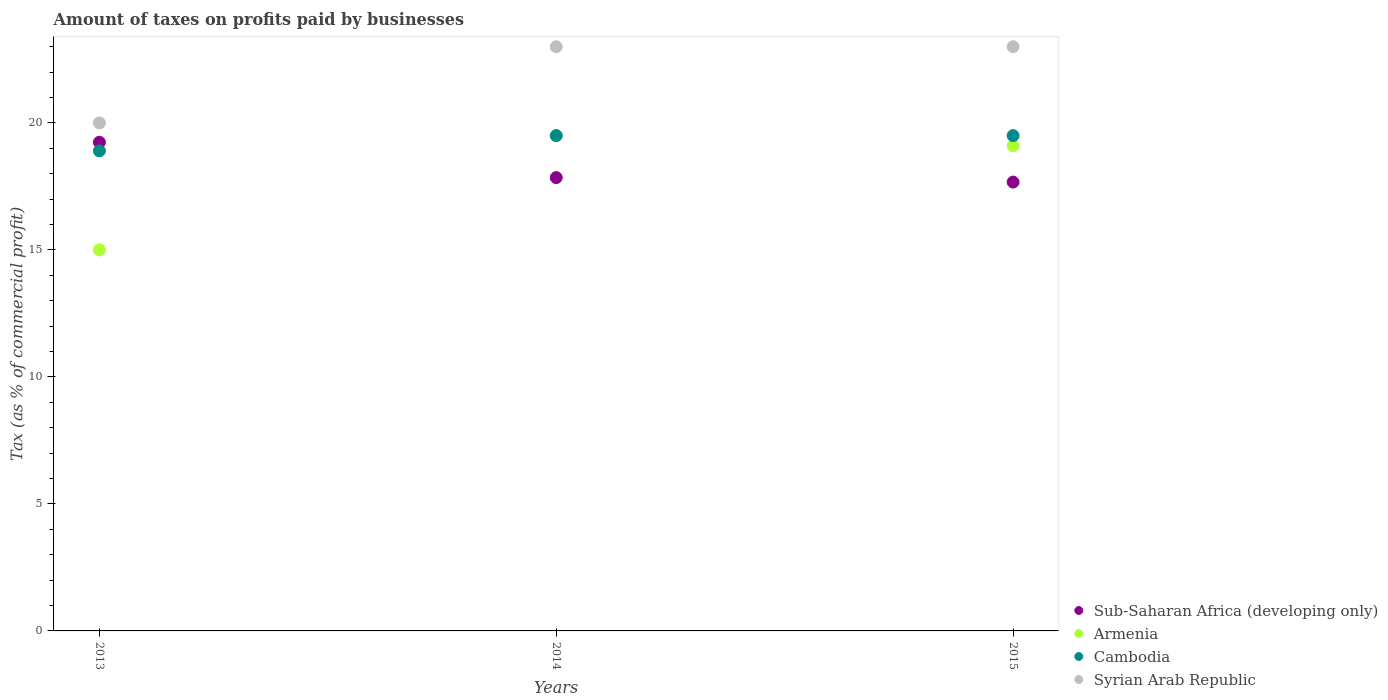Is the number of dotlines equal to the number of legend labels?
Offer a terse response. Yes. What is the percentage of taxes paid by businesses in Armenia in 2013?
Keep it short and to the point. 15. Across all years, what is the minimum percentage of taxes paid by businesses in Sub-Saharan Africa (developing only)?
Ensure brevity in your answer.  17.67. In which year was the percentage of taxes paid by businesses in Sub-Saharan Africa (developing only) maximum?
Keep it short and to the point. 2013. What is the total percentage of taxes paid by businesses in Cambodia in the graph?
Ensure brevity in your answer.  57.9. What is the difference between the percentage of taxes paid by businesses in Armenia in 2013 and that in 2014?
Your answer should be very brief. -4.5. What is the difference between the percentage of taxes paid by businesses in Cambodia in 2013 and the percentage of taxes paid by businesses in Armenia in 2014?
Your answer should be compact. -0.6. What is the average percentage of taxes paid by businesses in Armenia per year?
Ensure brevity in your answer.  17.87. In the year 2014, what is the difference between the percentage of taxes paid by businesses in Syrian Arab Republic and percentage of taxes paid by businesses in Cambodia?
Ensure brevity in your answer.  3.5. What is the ratio of the percentage of taxes paid by businesses in Syrian Arab Republic in 2013 to that in 2015?
Offer a very short reply. 0.87. Is the percentage of taxes paid by businesses in Sub-Saharan Africa (developing only) in 2013 less than that in 2014?
Provide a succinct answer. No. Is the difference between the percentage of taxes paid by businesses in Syrian Arab Republic in 2013 and 2015 greater than the difference between the percentage of taxes paid by businesses in Cambodia in 2013 and 2015?
Keep it short and to the point. No. What is the difference between the highest and the second highest percentage of taxes paid by businesses in Armenia?
Your response must be concise. 0.4. What is the difference between the highest and the lowest percentage of taxes paid by businesses in Syrian Arab Republic?
Ensure brevity in your answer.  3. Is the sum of the percentage of taxes paid by businesses in Sub-Saharan Africa (developing only) in 2013 and 2014 greater than the maximum percentage of taxes paid by businesses in Cambodia across all years?
Keep it short and to the point. Yes. Is it the case that in every year, the sum of the percentage of taxes paid by businesses in Armenia and percentage of taxes paid by businesses in Cambodia  is greater than the sum of percentage of taxes paid by businesses in Syrian Arab Republic and percentage of taxes paid by businesses in Sub-Saharan Africa (developing only)?
Provide a succinct answer. No. Does the percentage of taxes paid by businesses in Armenia monotonically increase over the years?
Offer a terse response. No. How many years are there in the graph?
Provide a succinct answer. 3. Are the values on the major ticks of Y-axis written in scientific E-notation?
Keep it short and to the point. No. Does the graph contain any zero values?
Provide a succinct answer. No. Does the graph contain grids?
Your response must be concise. No. What is the title of the graph?
Provide a succinct answer. Amount of taxes on profits paid by businesses. What is the label or title of the X-axis?
Provide a short and direct response. Years. What is the label or title of the Y-axis?
Your response must be concise. Tax (as % of commercial profit). What is the Tax (as % of commercial profit) of Sub-Saharan Africa (developing only) in 2013?
Offer a terse response. 19.24. What is the Tax (as % of commercial profit) in Cambodia in 2013?
Offer a very short reply. 18.9. What is the Tax (as % of commercial profit) of Syrian Arab Republic in 2013?
Make the answer very short. 20. What is the Tax (as % of commercial profit) in Sub-Saharan Africa (developing only) in 2014?
Make the answer very short. 17.85. What is the Tax (as % of commercial profit) in Syrian Arab Republic in 2014?
Ensure brevity in your answer.  23. What is the Tax (as % of commercial profit) of Sub-Saharan Africa (developing only) in 2015?
Your answer should be compact. 17.67. What is the Tax (as % of commercial profit) of Syrian Arab Republic in 2015?
Keep it short and to the point. 23. Across all years, what is the maximum Tax (as % of commercial profit) in Sub-Saharan Africa (developing only)?
Ensure brevity in your answer.  19.24. Across all years, what is the maximum Tax (as % of commercial profit) of Armenia?
Ensure brevity in your answer.  19.5. Across all years, what is the maximum Tax (as % of commercial profit) in Cambodia?
Your answer should be very brief. 19.5. Across all years, what is the minimum Tax (as % of commercial profit) of Sub-Saharan Africa (developing only)?
Ensure brevity in your answer.  17.67. Across all years, what is the minimum Tax (as % of commercial profit) in Cambodia?
Make the answer very short. 18.9. Across all years, what is the minimum Tax (as % of commercial profit) of Syrian Arab Republic?
Provide a short and direct response. 20. What is the total Tax (as % of commercial profit) of Sub-Saharan Africa (developing only) in the graph?
Your answer should be very brief. 54.76. What is the total Tax (as % of commercial profit) of Armenia in the graph?
Offer a terse response. 53.6. What is the total Tax (as % of commercial profit) in Cambodia in the graph?
Your answer should be compact. 57.9. What is the total Tax (as % of commercial profit) of Syrian Arab Republic in the graph?
Make the answer very short. 66. What is the difference between the Tax (as % of commercial profit) of Sub-Saharan Africa (developing only) in 2013 and that in 2014?
Ensure brevity in your answer.  1.39. What is the difference between the Tax (as % of commercial profit) of Armenia in 2013 and that in 2014?
Give a very brief answer. -4.5. What is the difference between the Tax (as % of commercial profit) in Sub-Saharan Africa (developing only) in 2013 and that in 2015?
Keep it short and to the point. 1.57. What is the difference between the Tax (as % of commercial profit) of Armenia in 2013 and that in 2015?
Your response must be concise. -4.1. What is the difference between the Tax (as % of commercial profit) in Sub-Saharan Africa (developing only) in 2014 and that in 2015?
Offer a terse response. 0.18. What is the difference between the Tax (as % of commercial profit) in Armenia in 2014 and that in 2015?
Keep it short and to the point. 0.4. What is the difference between the Tax (as % of commercial profit) in Cambodia in 2014 and that in 2015?
Make the answer very short. 0. What is the difference between the Tax (as % of commercial profit) in Sub-Saharan Africa (developing only) in 2013 and the Tax (as % of commercial profit) in Armenia in 2014?
Make the answer very short. -0.26. What is the difference between the Tax (as % of commercial profit) of Sub-Saharan Africa (developing only) in 2013 and the Tax (as % of commercial profit) of Cambodia in 2014?
Offer a terse response. -0.26. What is the difference between the Tax (as % of commercial profit) of Sub-Saharan Africa (developing only) in 2013 and the Tax (as % of commercial profit) of Syrian Arab Republic in 2014?
Give a very brief answer. -3.76. What is the difference between the Tax (as % of commercial profit) of Armenia in 2013 and the Tax (as % of commercial profit) of Cambodia in 2014?
Ensure brevity in your answer.  -4.5. What is the difference between the Tax (as % of commercial profit) of Armenia in 2013 and the Tax (as % of commercial profit) of Syrian Arab Republic in 2014?
Your answer should be compact. -8. What is the difference between the Tax (as % of commercial profit) of Sub-Saharan Africa (developing only) in 2013 and the Tax (as % of commercial profit) of Armenia in 2015?
Make the answer very short. 0.14. What is the difference between the Tax (as % of commercial profit) of Sub-Saharan Africa (developing only) in 2013 and the Tax (as % of commercial profit) of Cambodia in 2015?
Ensure brevity in your answer.  -0.26. What is the difference between the Tax (as % of commercial profit) of Sub-Saharan Africa (developing only) in 2013 and the Tax (as % of commercial profit) of Syrian Arab Republic in 2015?
Provide a short and direct response. -3.76. What is the difference between the Tax (as % of commercial profit) of Armenia in 2013 and the Tax (as % of commercial profit) of Cambodia in 2015?
Offer a very short reply. -4.5. What is the difference between the Tax (as % of commercial profit) in Armenia in 2013 and the Tax (as % of commercial profit) in Syrian Arab Republic in 2015?
Ensure brevity in your answer.  -8. What is the difference between the Tax (as % of commercial profit) of Cambodia in 2013 and the Tax (as % of commercial profit) of Syrian Arab Republic in 2015?
Your response must be concise. -4.1. What is the difference between the Tax (as % of commercial profit) of Sub-Saharan Africa (developing only) in 2014 and the Tax (as % of commercial profit) of Armenia in 2015?
Make the answer very short. -1.25. What is the difference between the Tax (as % of commercial profit) of Sub-Saharan Africa (developing only) in 2014 and the Tax (as % of commercial profit) of Cambodia in 2015?
Keep it short and to the point. -1.65. What is the difference between the Tax (as % of commercial profit) of Sub-Saharan Africa (developing only) in 2014 and the Tax (as % of commercial profit) of Syrian Arab Republic in 2015?
Offer a very short reply. -5.15. What is the difference between the Tax (as % of commercial profit) in Armenia in 2014 and the Tax (as % of commercial profit) in Syrian Arab Republic in 2015?
Make the answer very short. -3.5. What is the average Tax (as % of commercial profit) in Sub-Saharan Africa (developing only) per year?
Your answer should be compact. 18.25. What is the average Tax (as % of commercial profit) of Armenia per year?
Ensure brevity in your answer.  17.87. What is the average Tax (as % of commercial profit) of Cambodia per year?
Offer a terse response. 19.3. In the year 2013, what is the difference between the Tax (as % of commercial profit) in Sub-Saharan Africa (developing only) and Tax (as % of commercial profit) in Armenia?
Your response must be concise. 4.24. In the year 2013, what is the difference between the Tax (as % of commercial profit) of Sub-Saharan Africa (developing only) and Tax (as % of commercial profit) of Cambodia?
Your response must be concise. 0.34. In the year 2013, what is the difference between the Tax (as % of commercial profit) of Sub-Saharan Africa (developing only) and Tax (as % of commercial profit) of Syrian Arab Republic?
Ensure brevity in your answer.  -0.76. In the year 2013, what is the difference between the Tax (as % of commercial profit) in Armenia and Tax (as % of commercial profit) in Cambodia?
Give a very brief answer. -3.9. In the year 2014, what is the difference between the Tax (as % of commercial profit) in Sub-Saharan Africa (developing only) and Tax (as % of commercial profit) in Armenia?
Provide a succinct answer. -1.65. In the year 2014, what is the difference between the Tax (as % of commercial profit) of Sub-Saharan Africa (developing only) and Tax (as % of commercial profit) of Cambodia?
Your answer should be very brief. -1.65. In the year 2014, what is the difference between the Tax (as % of commercial profit) in Sub-Saharan Africa (developing only) and Tax (as % of commercial profit) in Syrian Arab Republic?
Your answer should be compact. -5.15. In the year 2014, what is the difference between the Tax (as % of commercial profit) of Armenia and Tax (as % of commercial profit) of Cambodia?
Provide a succinct answer. 0. In the year 2015, what is the difference between the Tax (as % of commercial profit) of Sub-Saharan Africa (developing only) and Tax (as % of commercial profit) of Armenia?
Your answer should be very brief. -1.43. In the year 2015, what is the difference between the Tax (as % of commercial profit) of Sub-Saharan Africa (developing only) and Tax (as % of commercial profit) of Cambodia?
Your response must be concise. -1.83. In the year 2015, what is the difference between the Tax (as % of commercial profit) of Sub-Saharan Africa (developing only) and Tax (as % of commercial profit) of Syrian Arab Republic?
Offer a terse response. -5.33. In the year 2015, what is the difference between the Tax (as % of commercial profit) of Armenia and Tax (as % of commercial profit) of Cambodia?
Ensure brevity in your answer.  -0.4. What is the ratio of the Tax (as % of commercial profit) in Sub-Saharan Africa (developing only) in 2013 to that in 2014?
Your response must be concise. 1.08. What is the ratio of the Tax (as % of commercial profit) of Armenia in 2013 to that in 2014?
Provide a succinct answer. 0.77. What is the ratio of the Tax (as % of commercial profit) in Cambodia in 2013 to that in 2014?
Provide a short and direct response. 0.97. What is the ratio of the Tax (as % of commercial profit) in Syrian Arab Republic in 2013 to that in 2014?
Your answer should be compact. 0.87. What is the ratio of the Tax (as % of commercial profit) in Sub-Saharan Africa (developing only) in 2013 to that in 2015?
Offer a terse response. 1.09. What is the ratio of the Tax (as % of commercial profit) of Armenia in 2013 to that in 2015?
Give a very brief answer. 0.79. What is the ratio of the Tax (as % of commercial profit) in Cambodia in 2013 to that in 2015?
Keep it short and to the point. 0.97. What is the ratio of the Tax (as % of commercial profit) of Syrian Arab Republic in 2013 to that in 2015?
Offer a terse response. 0.87. What is the ratio of the Tax (as % of commercial profit) of Sub-Saharan Africa (developing only) in 2014 to that in 2015?
Your answer should be compact. 1.01. What is the ratio of the Tax (as % of commercial profit) in Armenia in 2014 to that in 2015?
Keep it short and to the point. 1.02. What is the difference between the highest and the second highest Tax (as % of commercial profit) of Sub-Saharan Africa (developing only)?
Give a very brief answer. 1.39. What is the difference between the highest and the second highest Tax (as % of commercial profit) in Armenia?
Keep it short and to the point. 0.4. What is the difference between the highest and the lowest Tax (as % of commercial profit) of Sub-Saharan Africa (developing only)?
Provide a succinct answer. 1.57. 